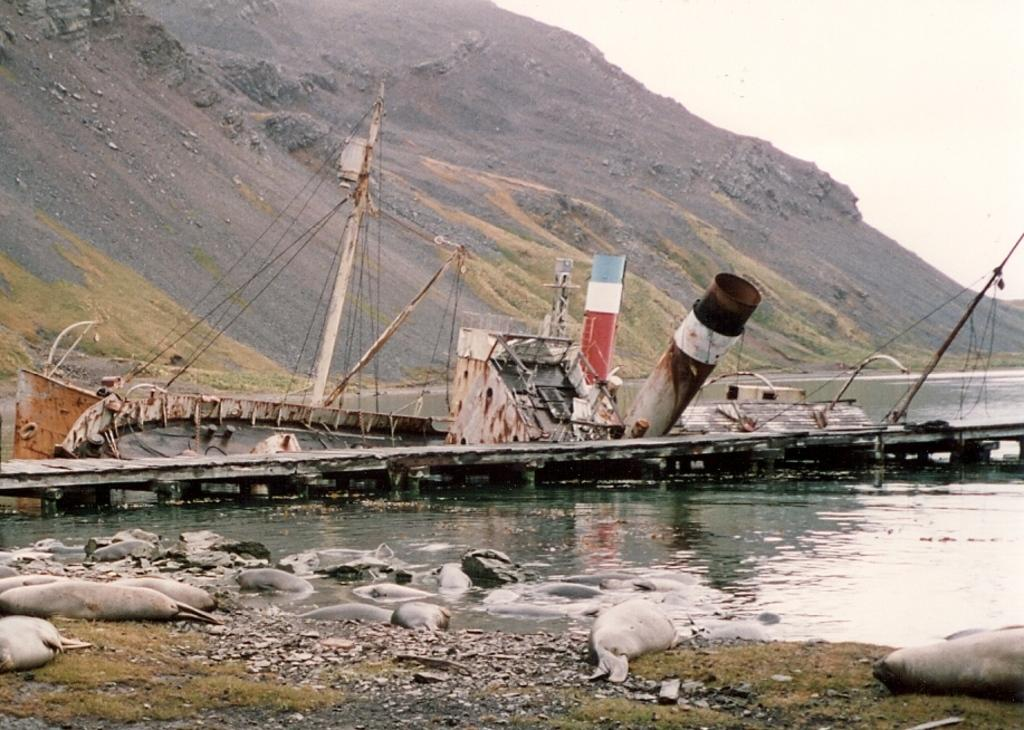What is in the water in the image? There is a boat in the water and sea animals in the water. What else can be seen in the image besides the boat and sea animals? There are sea animals on the path. What type of chalk is being used to draw on the boat in the image? There is no chalk present in the image, and no drawing activity is taking place on the boat. 